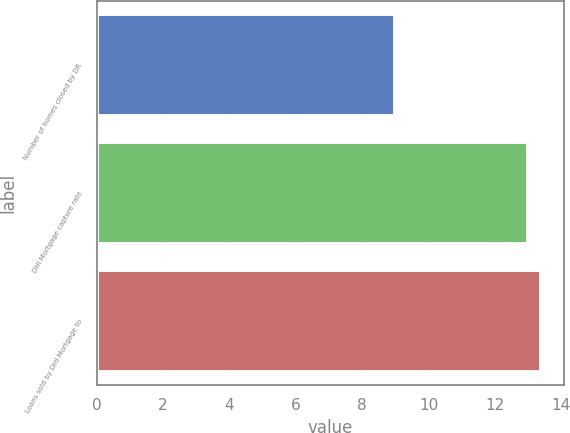Convert chart. <chart><loc_0><loc_0><loc_500><loc_500><bar_chart><fcel>Number of homes closed by DR<fcel>DHI Mortgage capture rate<fcel>Loans sold by DHI Mortgage to<nl><fcel>9<fcel>13<fcel>13.4<nl></chart> 